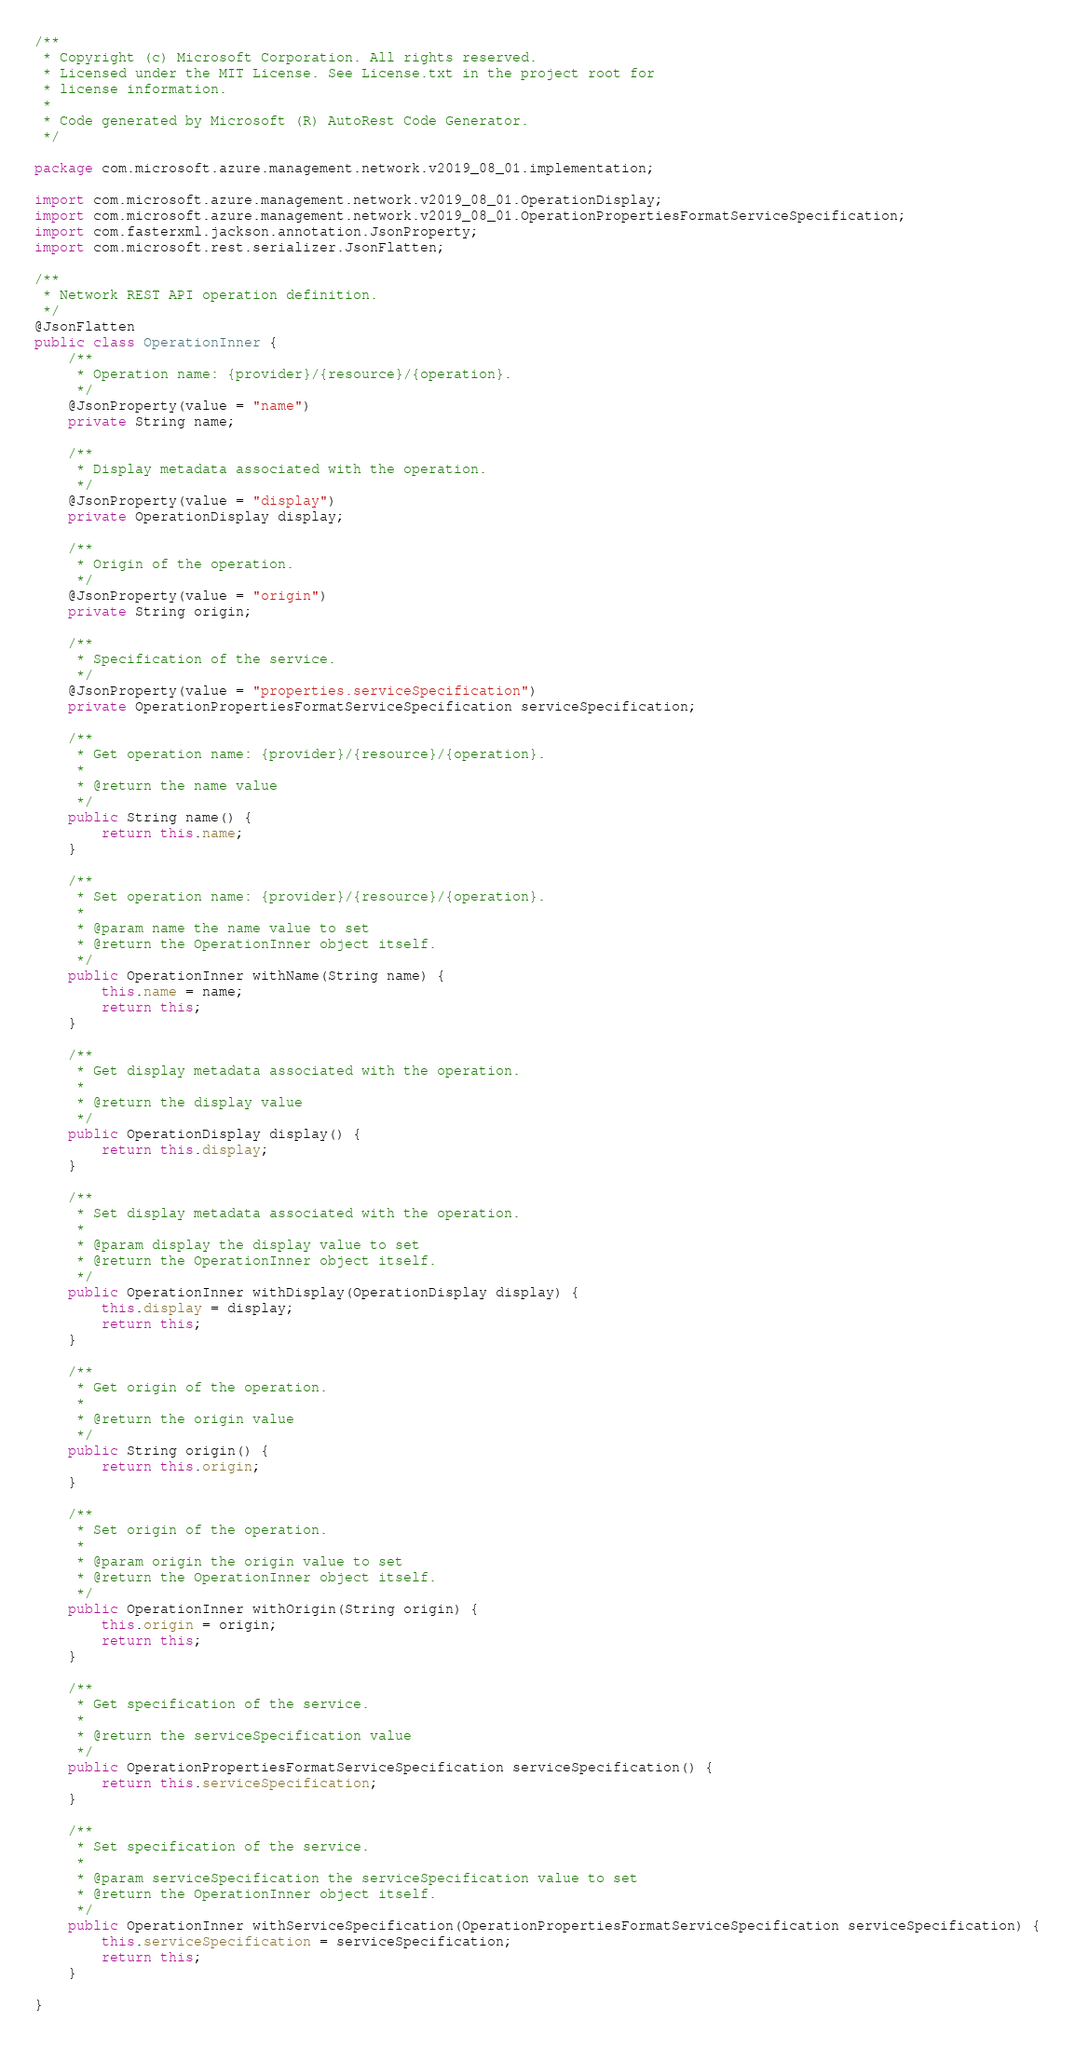Convert code to text. <code><loc_0><loc_0><loc_500><loc_500><_Java_>/**
 * Copyright (c) Microsoft Corporation. All rights reserved.
 * Licensed under the MIT License. See License.txt in the project root for
 * license information.
 *
 * Code generated by Microsoft (R) AutoRest Code Generator.
 */

package com.microsoft.azure.management.network.v2019_08_01.implementation;

import com.microsoft.azure.management.network.v2019_08_01.OperationDisplay;
import com.microsoft.azure.management.network.v2019_08_01.OperationPropertiesFormatServiceSpecification;
import com.fasterxml.jackson.annotation.JsonProperty;
import com.microsoft.rest.serializer.JsonFlatten;

/**
 * Network REST API operation definition.
 */
@JsonFlatten
public class OperationInner {
    /**
     * Operation name: {provider}/{resource}/{operation}.
     */
    @JsonProperty(value = "name")
    private String name;

    /**
     * Display metadata associated with the operation.
     */
    @JsonProperty(value = "display")
    private OperationDisplay display;

    /**
     * Origin of the operation.
     */
    @JsonProperty(value = "origin")
    private String origin;

    /**
     * Specification of the service.
     */
    @JsonProperty(value = "properties.serviceSpecification")
    private OperationPropertiesFormatServiceSpecification serviceSpecification;

    /**
     * Get operation name: {provider}/{resource}/{operation}.
     *
     * @return the name value
     */
    public String name() {
        return this.name;
    }

    /**
     * Set operation name: {provider}/{resource}/{operation}.
     *
     * @param name the name value to set
     * @return the OperationInner object itself.
     */
    public OperationInner withName(String name) {
        this.name = name;
        return this;
    }

    /**
     * Get display metadata associated with the operation.
     *
     * @return the display value
     */
    public OperationDisplay display() {
        return this.display;
    }

    /**
     * Set display metadata associated with the operation.
     *
     * @param display the display value to set
     * @return the OperationInner object itself.
     */
    public OperationInner withDisplay(OperationDisplay display) {
        this.display = display;
        return this;
    }

    /**
     * Get origin of the operation.
     *
     * @return the origin value
     */
    public String origin() {
        return this.origin;
    }

    /**
     * Set origin of the operation.
     *
     * @param origin the origin value to set
     * @return the OperationInner object itself.
     */
    public OperationInner withOrigin(String origin) {
        this.origin = origin;
        return this;
    }

    /**
     * Get specification of the service.
     *
     * @return the serviceSpecification value
     */
    public OperationPropertiesFormatServiceSpecification serviceSpecification() {
        return this.serviceSpecification;
    }

    /**
     * Set specification of the service.
     *
     * @param serviceSpecification the serviceSpecification value to set
     * @return the OperationInner object itself.
     */
    public OperationInner withServiceSpecification(OperationPropertiesFormatServiceSpecification serviceSpecification) {
        this.serviceSpecification = serviceSpecification;
        return this;
    }

}
</code> 